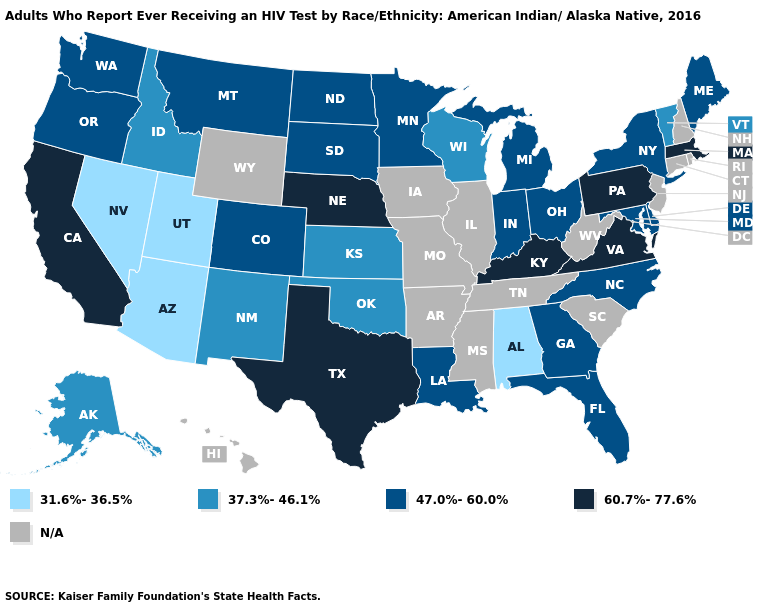What is the lowest value in the USA?
Write a very short answer. 31.6%-36.5%. What is the value of Texas?
Write a very short answer. 60.7%-77.6%. Among the states that border Arizona , which have the highest value?
Quick response, please. California. How many symbols are there in the legend?
Give a very brief answer. 5. Among the states that border Arkansas , does Texas have the lowest value?
Give a very brief answer. No. Which states hav the highest value in the West?
Keep it brief. California. Does Florida have the highest value in the South?
Quick response, please. No. Does Indiana have the lowest value in the USA?
Short answer required. No. Name the states that have a value in the range 31.6%-36.5%?
Concise answer only. Alabama, Arizona, Nevada, Utah. Name the states that have a value in the range 60.7%-77.6%?
Be succinct. California, Kentucky, Massachusetts, Nebraska, Pennsylvania, Texas, Virginia. Does the map have missing data?
Quick response, please. Yes. What is the value of Wisconsin?
Concise answer only. 37.3%-46.1%. Name the states that have a value in the range 31.6%-36.5%?
Write a very short answer. Alabama, Arizona, Nevada, Utah. What is the value of California?
Keep it brief. 60.7%-77.6%. What is the value of Kentucky?
Concise answer only. 60.7%-77.6%. 